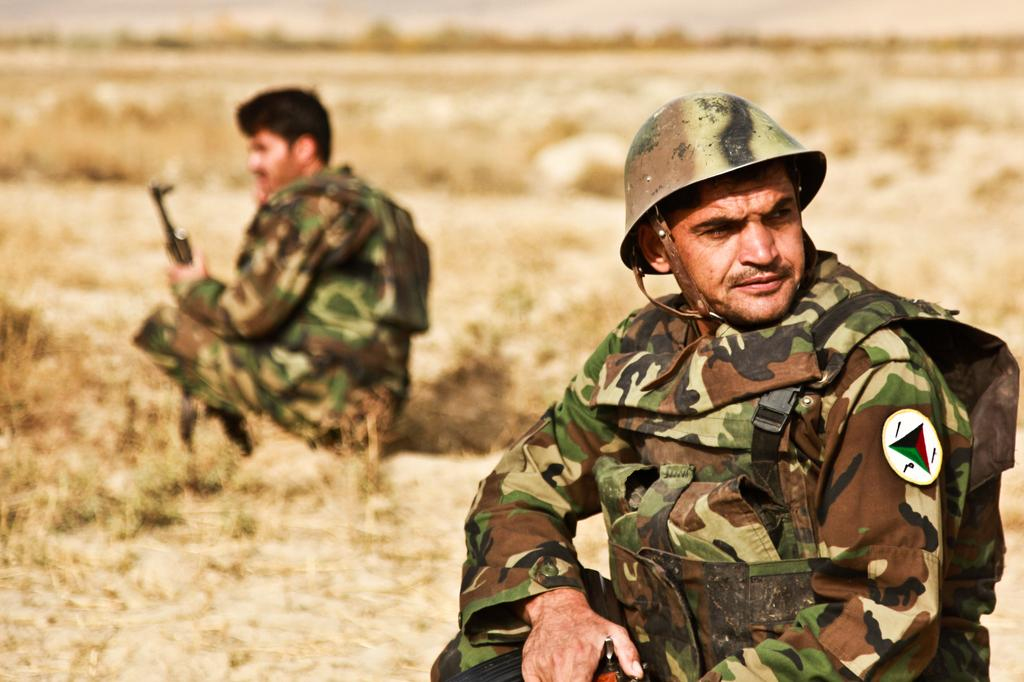How many people are in the image? There are two people in the image. What are the two people wearing? The two people are wearing military dress. What are the two people holding? The two people are holding guns. Can you describe the background of the image? The background of the image is blurred. What type of locket can be seen hanging from the gun in the image? There is no locket present in the image, and the guns are not depicted as having any attachments. 